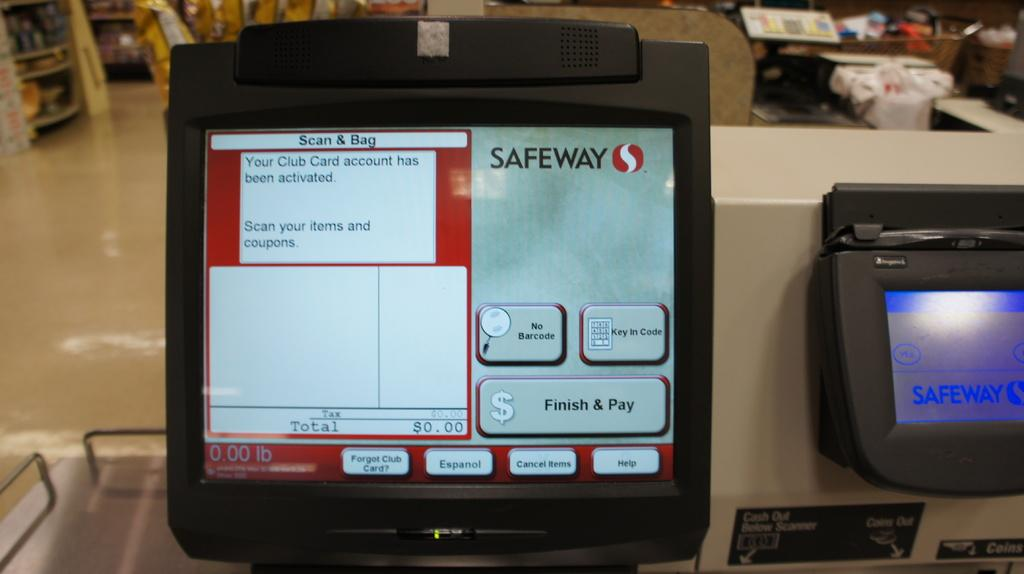<image>
Summarize the visual content of the image. Safeway features a self-checkout system which is compatible with their club program. 